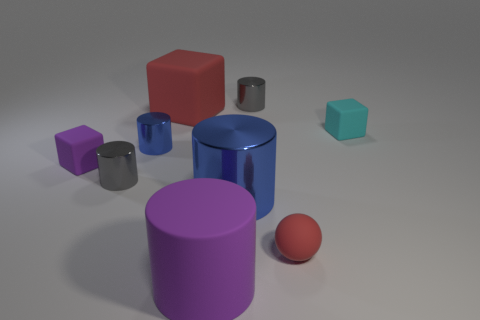Is there any other thing that has the same material as the red sphere?
Provide a short and direct response. Yes. Is there a tiny cylinder?
Offer a very short reply. Yes. Are the blue object right of the large red matte object and the big block made of the same material?
Offer a very short reply. No. Are there any red rubber objects of the same shape as the cyan object?
Give a very brief answer. Yes. Are there the same number of small gray metallic objects behind the tiny blue thing and big red cubes?
Your answer should be compact. Yes. There is a tiny gray thing that is on the right side of the small gray cylinder that is in front of the tiny purple matte object; what is it made of?
Make the answer very short. Metal. What is the shape of the big blue object?
Ensure brevity in your answer.  Cylinder. Are there an equal number of large things on the right side of the large purple cylinder and objects behind the small purple rubber thing?
Provide a short and direct response. No. Is the color of the small cylinder that is in front of the tiny purple matte block the same as the tiny shiny object on the right side of the big blue metallic object?
Offer a very short reply. Yes. Is the number of gray cylinders to the left of the big metal cylinder greater than the number of big gray rubber things?
Give a very brief answer. Yes. 